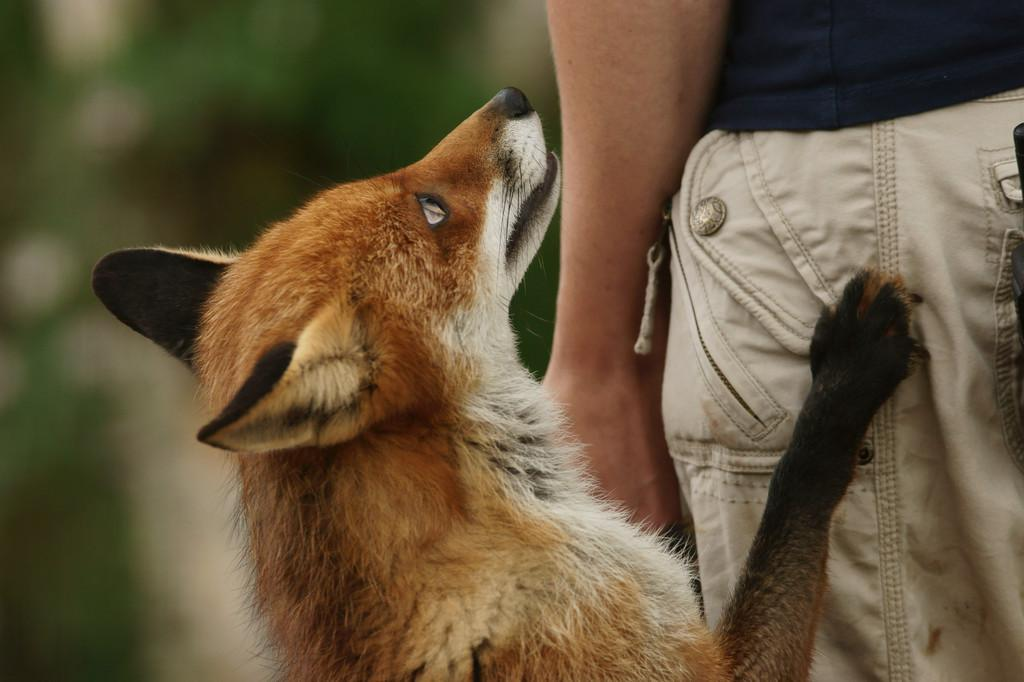Who is present in the image? There is a man in the image. Where is the man located in the image? The man is on the right side of the image. What other living creature is in the image? There is a dog in the image. Where is the dog positioned in the image? The dog is in the center of the image. What type of waves can be seen in the image? There are no waves present in the image. Is there a birthday celebration happening in the image? There is no indication of a birthday celebration in the image. 